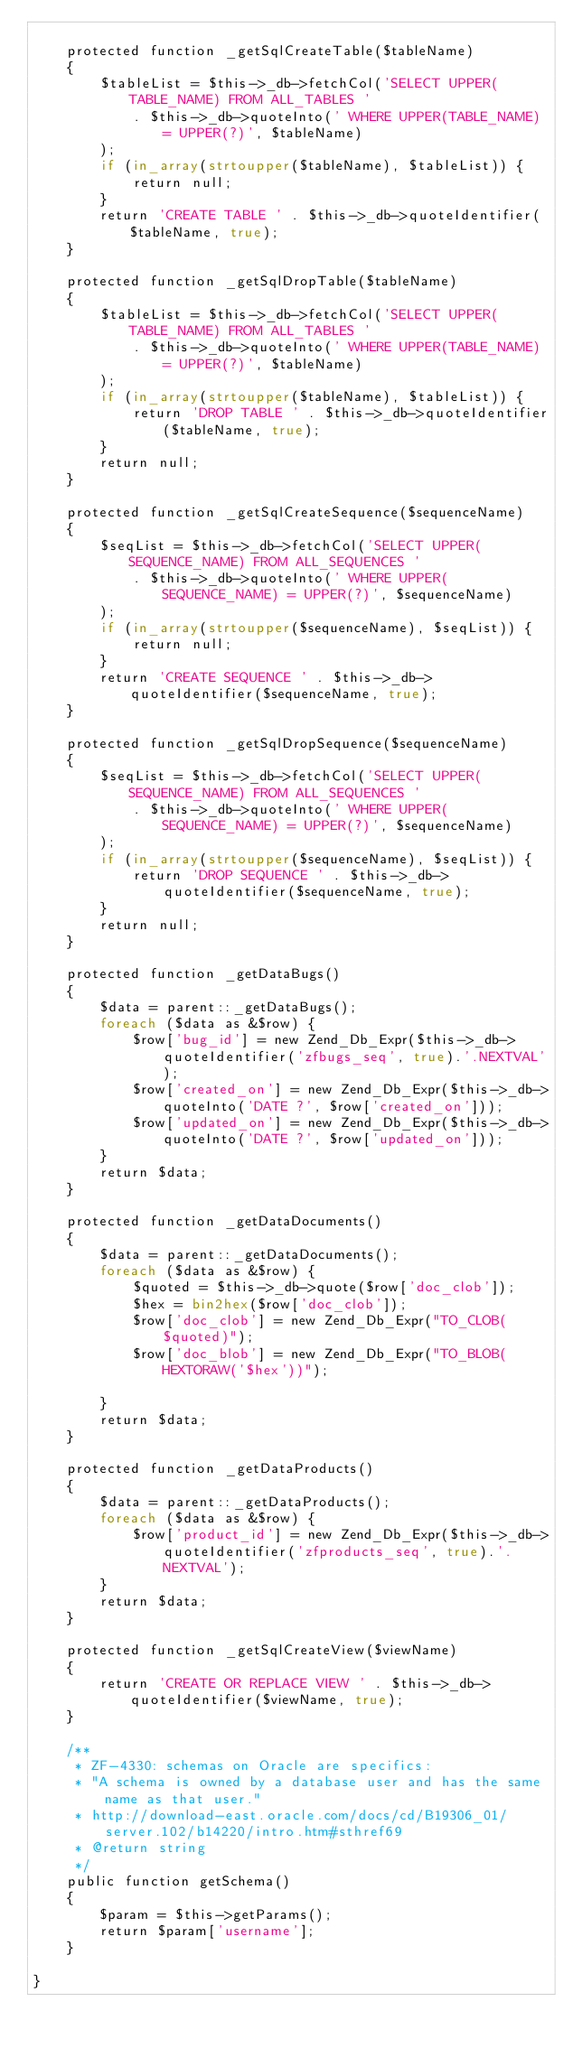<code> <loc_0><loc_0><loc_500><loc_500><_PHP_>
    protected function _getSqlCreateTable($tableName)
    {
        $tableList = $this->_db->fetchCol('SELECT UPPER(TABLE_NAME) FROM ALL_TABLES '
            . $this->_db->quoteInto(' WHERE UPPER(TABLE_NAME) = UPPER(?)', $tableName)
        );
        if (in_array(strtoupper($tableName), $tableList)) {
            return null;
        }
        return 'CREATE TABLE ' . $this->_db->quoteIdentifier($tableName, true);
    }

    protected function _getSqlDropTable($tableName)
    {
        $tableList = $this->_db->fetchCol('SELECT UPPER(TABLE_NAME) FROM ALL_TABLES '
            . $this->_db->quoteInto(' WHERE UPPER(TABLE_NAME) = UPPER(?)', $tableName)
        );
        if (in_array(strtoupper($tableName), $tableList)) {
            return 'DROP TABLE ' . $this->_db->quoteIdentifier($tableName, true);
        }
        return null;
    }

    protected function _getSqlCreateSequence($sequenceName)
    {
        $seqList = $this->_db->fetchCol('SELECT UPPER(SEQUENCE_NAME) FROM ALL_SEQUENCES '
            . $this->_db->quoteInto(' WHERE UPPER(SEQUENCE_NAME) = UPPER(?)', $sequenceName)
        );
        if (in_array(strtoupper($sequenceName), $seqList)) {
            return null;
        }
        return 'CREATE SEQUENCE ' . $this->_db->quoteIdentifier($sequenceName, true);
    }

    protected function _getSqlDropSequence($sequenceName)
    {
        $seqList = $this->_db->fetchCol('SELECT UPPER(SEQUENCE_NAME) FROM ALL_SEQUENCES '
            . $this->_db->quoteInto(' WHERE UPPER(SEQUENCE_NAME) = UPPER(?)', $sequenceName)
        );
        if (in_array(strtoupper($sequenceName), $seqList)) {
            return 'DROP SEQUENCE ' . $this->_db->quoteIdentifier($sequenceName, true);
        }
        return null;
    }

    protected function _getDataBugs()
    {
        $data = parent::_getDataBugs();
        foreach ($data as &$row) {
            $row['bug_id'] = new Zend_Db_Expr($this->_db->quoteIdentifier('zfbugs_seq', true).'.NEXTVAL');
            $row['created_on'] = new Zend_Db_Expr($this->_db->quoteInto('DATE ?', $row['created_on']));
            $row['updated_on'] = new Zend_Db_Expr($this->_db->quoteInto('DATE ?', $row['updated_on']));
        }
        return $data;
    }

    protected function _getDataDocuments()
    {
        $data = parent::_getDataDocuments();
        foreach ($data as &$row) {
            $quoted = $this->_db->quote($row['doc_clob']);
            $hex = bin2hex($row['doc_clob']);
            $row['doc_clob'] = new Zend_Db_Expr("TO_CLOB($quoted)");
            $row['doc_blob'] = new Zend_Db_Expr("TO_BLOB(HEXTORAW('$hex'))");

        }
        return $data;
    }

    protected function _getDataProducts()
    {
        $data = parent::_getDataProducts();
        foreach ($data as &$row) {
            $row['product_id'] = new Zend_Db_Expr($this->_db->quoteIdentifier('zfproducts_seq', true).'.NEXTVAL');
        }
        return $data;
    }

    protected function _getSqlCreateView($viewName)
    {
        return 'CREATE OR REPLACE VIEW ' . $this->_db->quoteIdentifier($viewName, true);
    }

    /**
     * ZF-4330: schemas on Oracle are specifics:
     * "A schema is owned by a database user and has the same name as that user."
     * http://download-east.oracle.com/docs/cd/B19306_01/server.102/b14220/intro.htm#sthref69
     * @return string
     */
    public function getSchema()
    {
        $param = $this->getParams();
        return $param['username'];
    }

}
</code> 